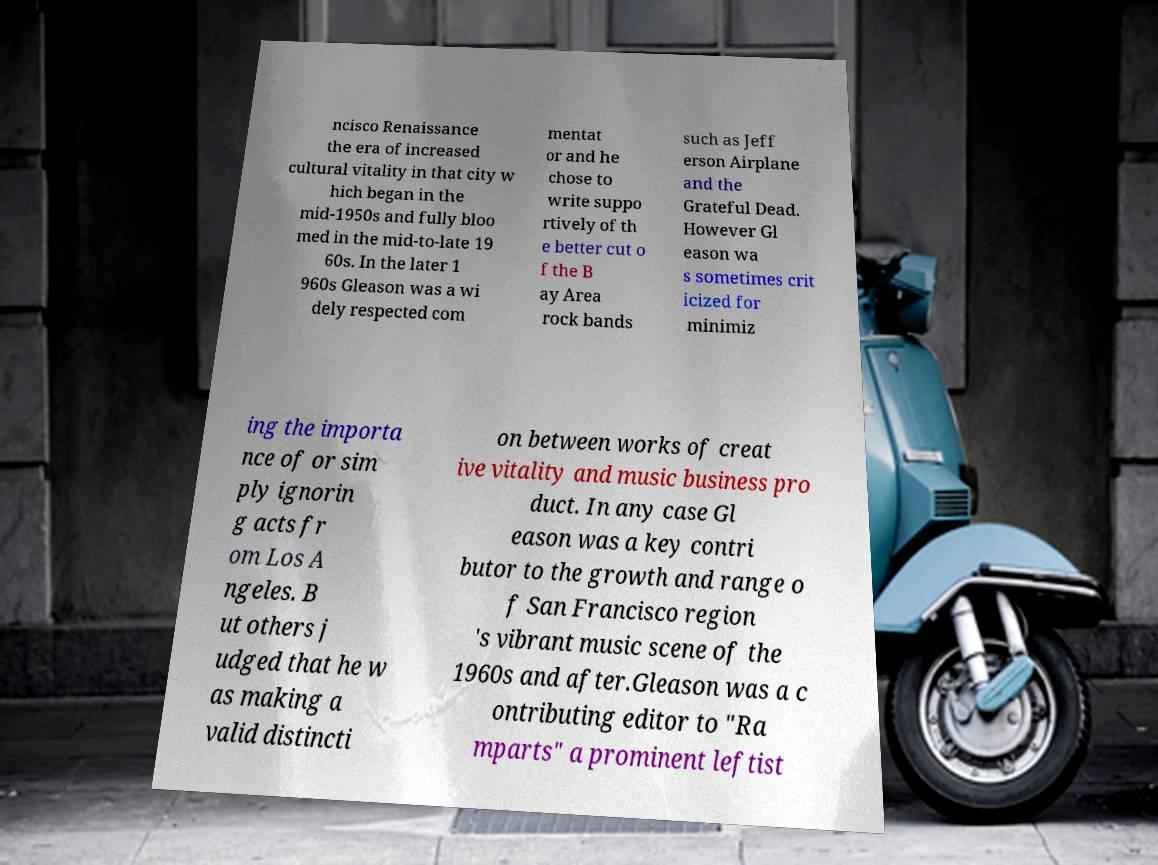I need the written content from this picture converted into text. Can you do that? ncisco Renaissance the era of increased cultural vitality in that city w hich began in the mid-1950s and fully bloo med in the mid-to-late 19 60s. In the later 1 960s Gleason was a wi dely respected com mentat or and he chose to write suppo rtively of th e better cut o f the B ay Area rock bands such as Jeff erson Airplane and the Grateful Dead. However Gl eason wa s sometimes crit icized for minimiz ing the importa nce of or sim ply ignorin g acts fr om Los A ngeles. B ut others j udged that he w as making a valid distincti on between works of creat ive vitality and music business pro duct. In any case Gl eason was a key contri butor to the growth and range o f San Francisco region 's vibrant music scene of the 1960s and after.Gleason was a c ontributing editor to "Ra mparts" a prominent leftist 